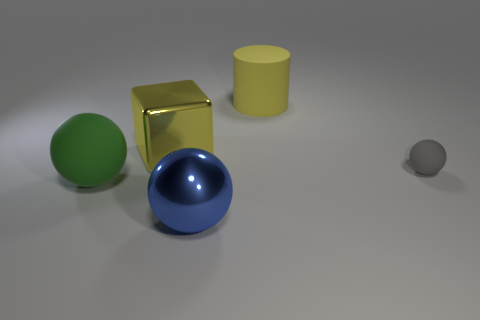Is the shape of the big shiny object that is behind the big rubber ball the same as  the blue metallic thing?
Ensure brevity in your answer.  No. The large rubber thing on the right side of the green object has what shape?
Give a very brief answer. Cylinder. The big object that is the same color as the big cube is what shape?
Ensure brevity in your answer.  Cylinder. What number of balls have the same size as the green object?
Your response must be concise. 1. The tiny thing has what color?
Offer a terse response. Gray. There is a cylinder; is its color the same as the tiny matte sphere that is in front of the large block?
Ensure brevity in your answer.  No. What size is the ball that is made of the same material as the large block?
Your response must be concise. Large. Are there any large objects of the same color as the cylinder?
Your response must be concise. Yes. What number of objects are rubber things to the right of the big yellow cylinder or large green matte balls?
Keep it short and to the point. 2. Do the small gray sphere and the yellow object that is left of the blue shiny thing have the same material?
Offer a very short reply. No. 